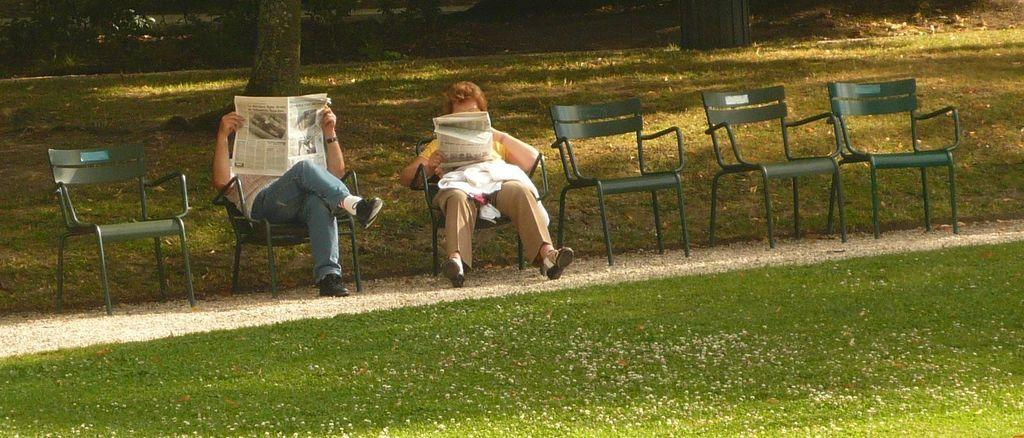How many people are in the image? There are two people in the image. What are the people doing in the image? The people are sitting on chairs and reading newspapers. Are there any empty chairs in the image? Yes, there are empty chairs beside the people. What can be seen in front of the people? There is grass in front of the people. What is visible behind the people? There are trees behind the people. What type of knowledge is the person on the left writing down in the image? There is no person writing in the image; both people are reading newspapers. 